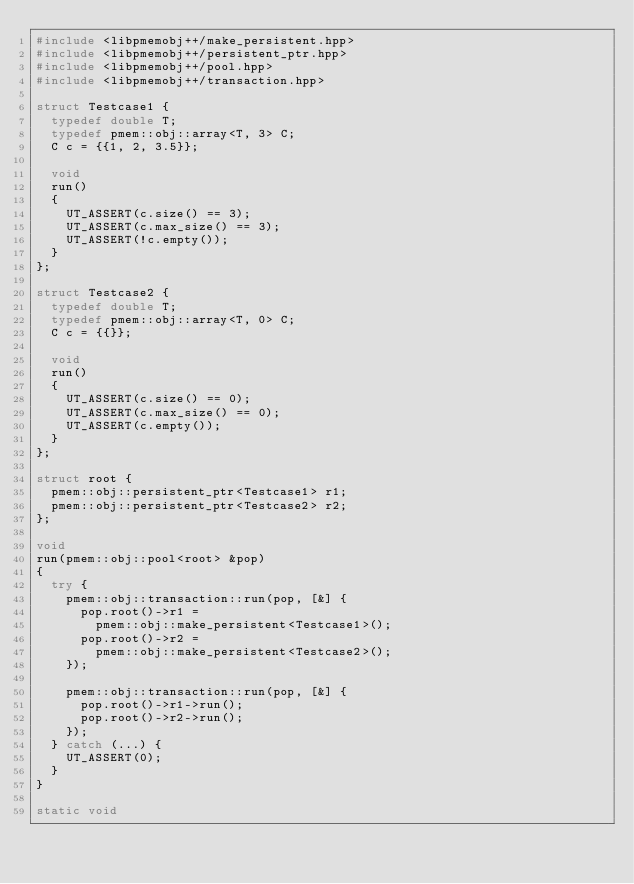<code> <loc_0><loc_0><loc_500><loc_500><_C++_>#include <libpmemobj++/make_persistent.hpp>
#include <libpmemobj++/persistent_ptr.hpp>
#include <libpmemobj++/pool.hpp>
#include <libpmemobj++/transaction.hpp>

struct Testcase1 {
	typedef double T;
	typedef pmem::obj::array<T, 3> C;
	C c = {{1, 2, 3.5}};

	void
	run()
	{
		UT_ASSERT(c.size() == 3);
		UT_ASSERT(c.max_size() == 3);
		UT_ASSERT(!c.empty());
	}
};

struct Testcase2 {
	typedef double T;
	typedef pmem::obj::array<T, 0> C;
	C c = {{}};

	void
	run()
	{
		UT_ASSERT(c.size() == 0);
		UT_ASSERT(c.max_size() == 0);
		UT_ASSERT(c.empty());
	}
};

struct root {
	pmem::obj::persistent_ptr<Testcase1> r1;
	pmem::obj::persistent_ptr<Testcase2> r2;
};

void
run(pmem::obj::pool<root> &pop)
{
	try {
		pmem::obj::transaction::run(pop, [&] {
			pop.root()->r1 =
				pmem::obj::make_persistent<Testcase1>();
			pop.root()->r2 =
				pmem::obj::make_persistent<Testcase2>();
		});

		pmem::obj::transaction::run(pop, [&] {
			pop.root()->r1->run();
			pop.root()->r2->run();
		});
	} catch (...) {
		UT_ASSERT(0);
	}
}

static void</code> 